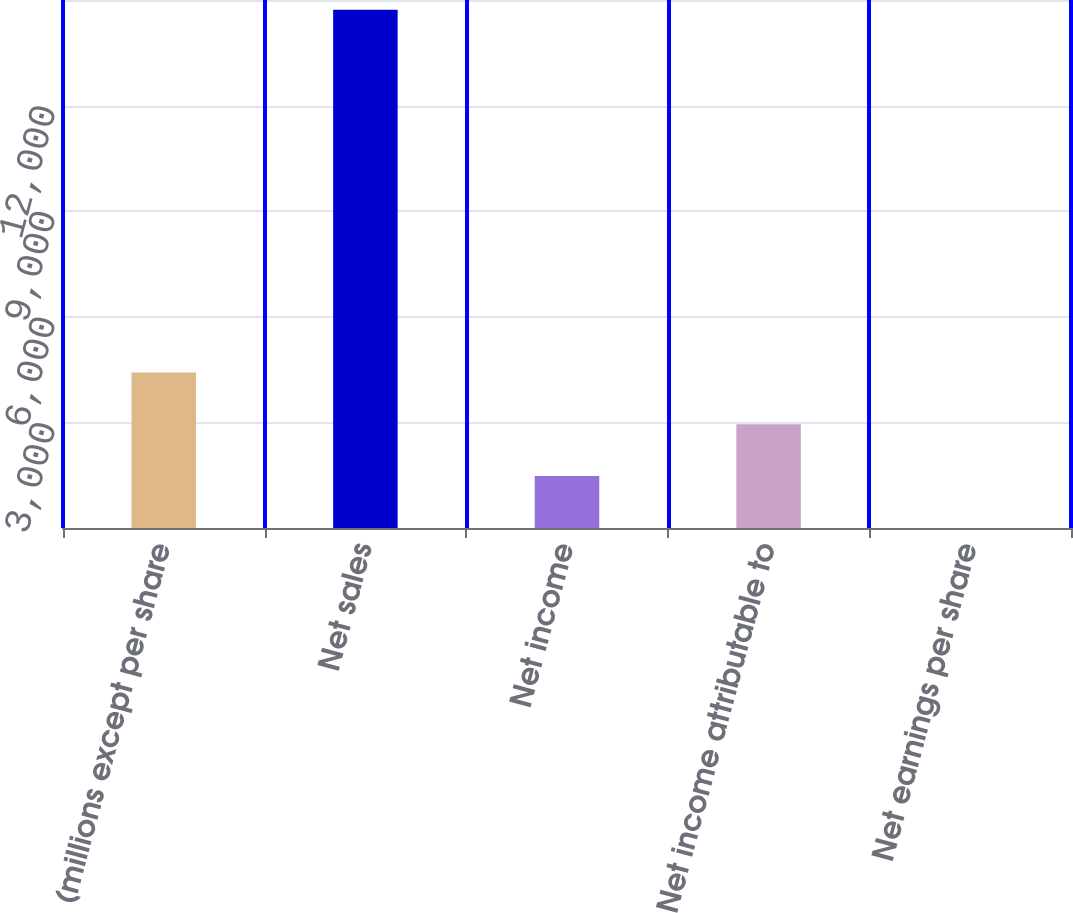<chart> <loc_0><loc_0><loc_500><loc_500><bar_chart><fcel>(millions except per share<fcel>Net sales<fcel>Net income<fcel>Net income attributable to<fcel>Net earnings per share<nl><fcel>4418.42<fcel>14722<fcel>1474.54<fcel>2946.48<fcel>2.6<nl></chart> 